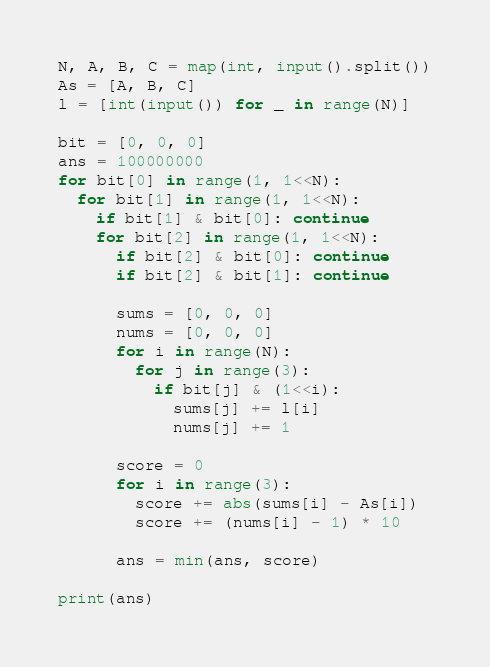<code> <loc_0><loc_0><loc_500><loc_500><_Python_>N, A, B, C = map(int, input().split())
As = [A, B, C]
l = [int(input()) for _ in range(N)]

bit = [0, 0, 0]
ans = 100000000
for bit[0] in range(1, 1<<N):
  for bit[1] in range(1, 1<<N):
    if bit[1] & bit[0]: continue
    for bit[2] in range(1, 1<<N):
      if bit[2] & bit[0]: continue
      if bit[2] & bit[1]: continue

      sums = [0, 0, 0]
      nums = [0, 0, 0]
      for i in range(N):
        for j in range(3):
          if bit[j] & (1<<i):
            sums[j] += l[i]
            nums[j] += 1

      score = 0
      for i in range(3):
        score += abs(sums[i] - As[i])
        score += (nums[i] - 1) * 10

      ans = min(ans, score)

print(ans)
</code> 